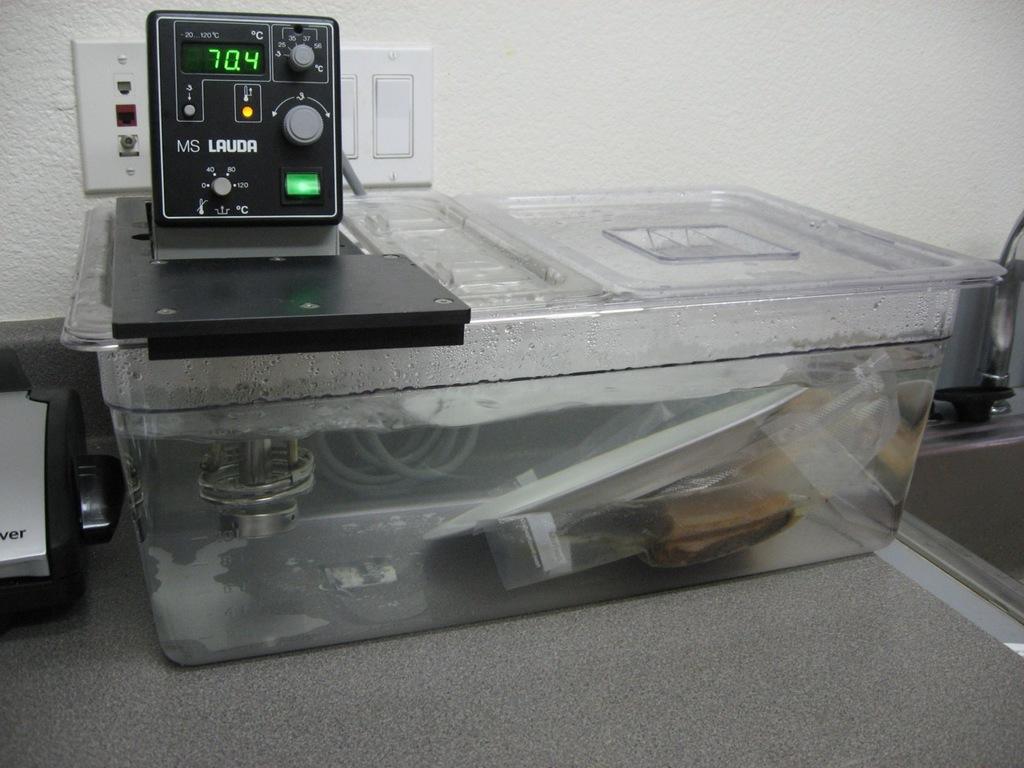What does the lauda say?
Your answer should be very brief. 70.4. 